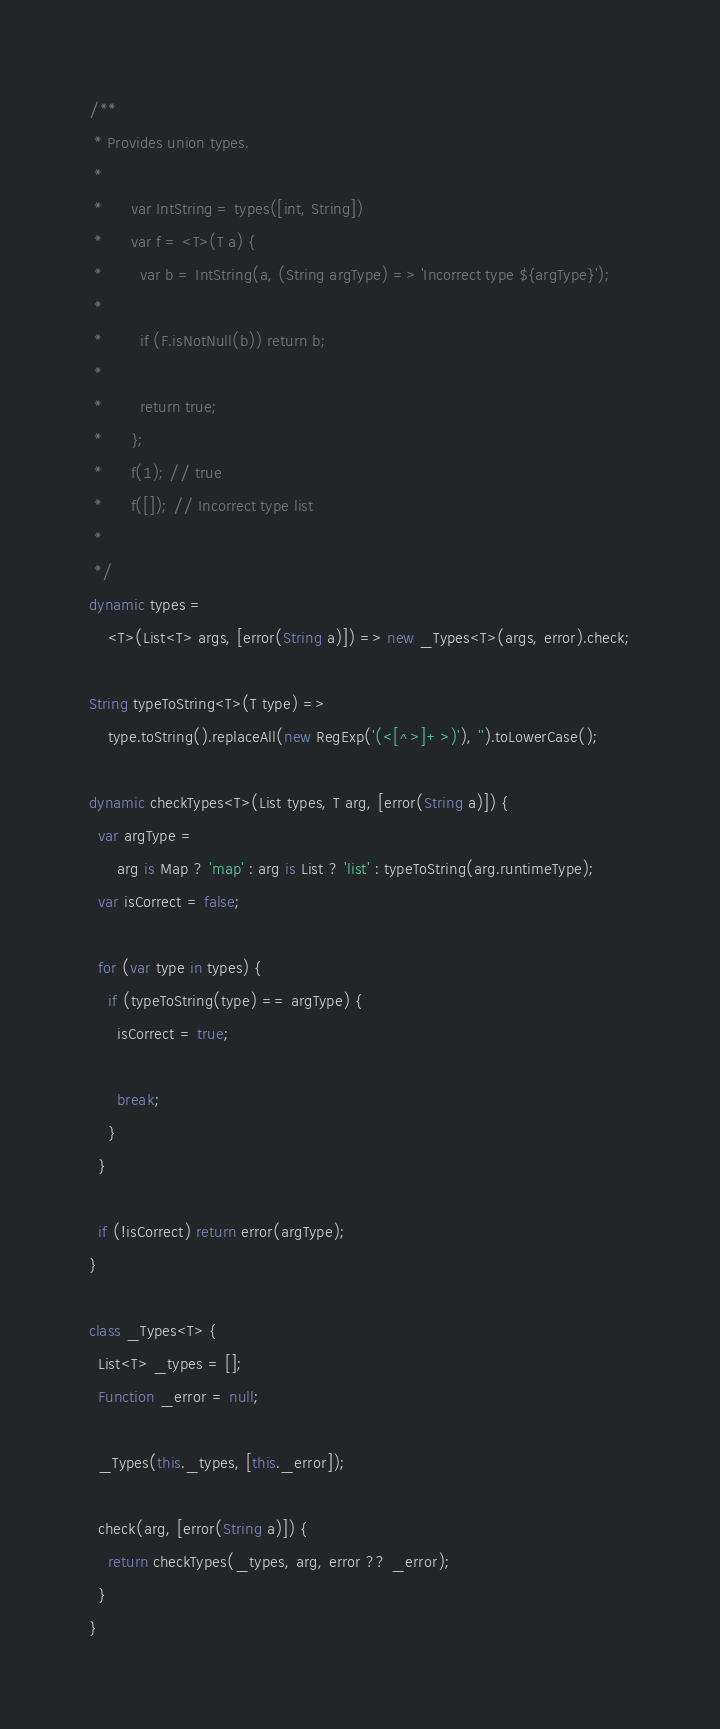Convert code to text. <code><loc_0><loc_0><loc_500><loc_500><_Dart_>/**
 * Provides union types.
 * 
 *      var IntString = types([int, String])
 *      var f = <T>(T a) {
 *        var b = IntString(a, (String argType) => 'Incorrect type ${argType}');
 *
 *        if (F.isNotNull(b)) return b;
 *
 *        return true;
 *      };
 *      f(1); // true
 *      f([]); // Incorrect type list
 * 
 */
dynamic types =
    <T>(List<T> args, [error(String a)]) => new _Types<T>(args, error).check;

String typeToString<T>(T type) =>
    type.toString().replaceAll(new RegExp('(<[^>]+>)'), '').toLowerCase();

dynamic checkTypes<T>(List types, T arg, [error(String a)]) {
  var argType =
      arg is Map ? 'map' : arg is List ? 'list' : typeToString(arg.runtimeType);
  var isCorrect = false;

  for (var type in types) {
    if (typeToString(type) == argType) {
      isCorrect = true;

      break;
    }
  }

  if (!isCorrect) return error(argType);
}

class _Types<T> {
  List<T> _types = [];
  Function _error = null;

  _Types(this._types, [this._error]);

  check(arg, [error(String a)]) {
    return checkTypes(_types, arg, error ?? _error);
  }
}
</code> 